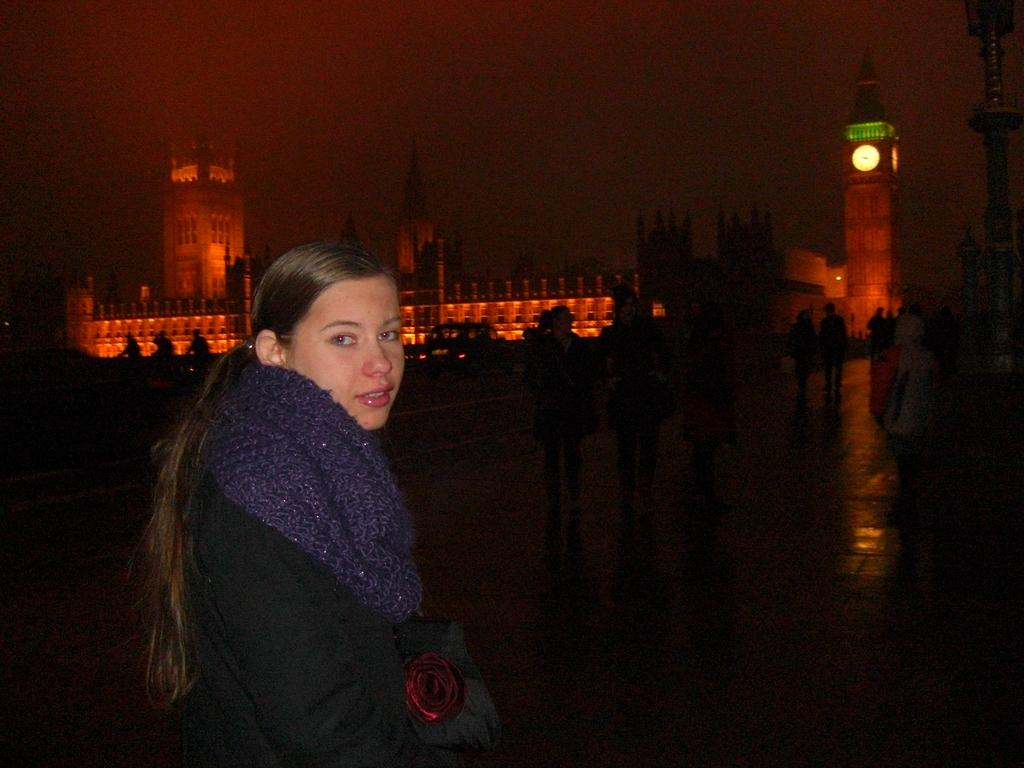What is the main subject on the left side of the image? There is a lady standing on the left side of the image. What is the lady wearing around her neck? The lady is wearing a neck scarf. What can be seen in the background of the image? There are people and towers visible in the background. What is visible at the top of the image? The sky is visible at the top of the image. How many pets does the lady have in the image? There is no indication of any pets in the image. What type of wound is the lady treating on her uncle's arm in the image? There is no uncle or wound present in the image. 